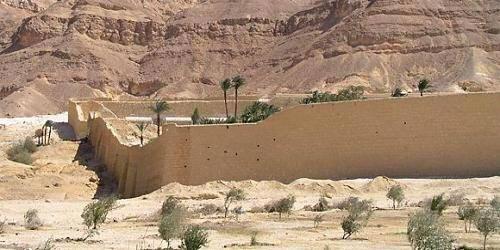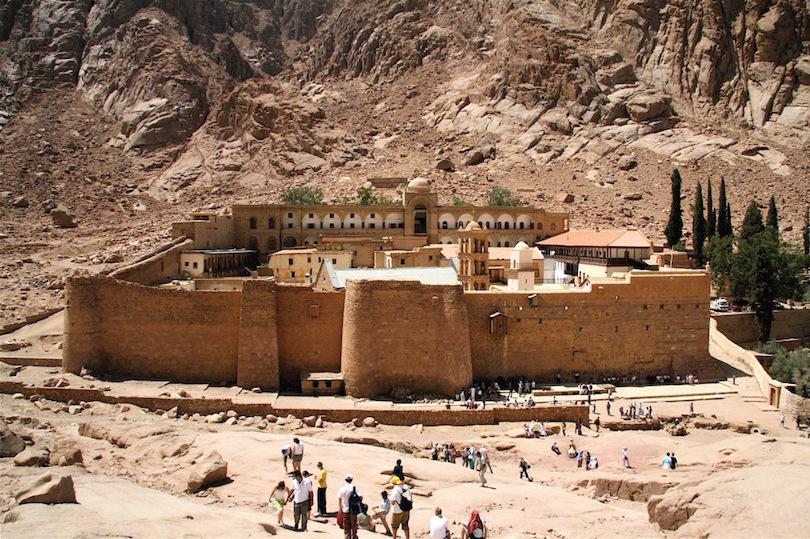The first image is the image on the left, the second image is the image on the right. Assess this claim about the two images: "In at least one image there is a single castle facing forward.". Correct or not? Answer yes or no. Yes. The first image is the image on the left, the second image is the image on the right. Considering the images on both sides, is "All of the boundaries are shown for one walled city in each image." valid? Answer yes or no. No. 